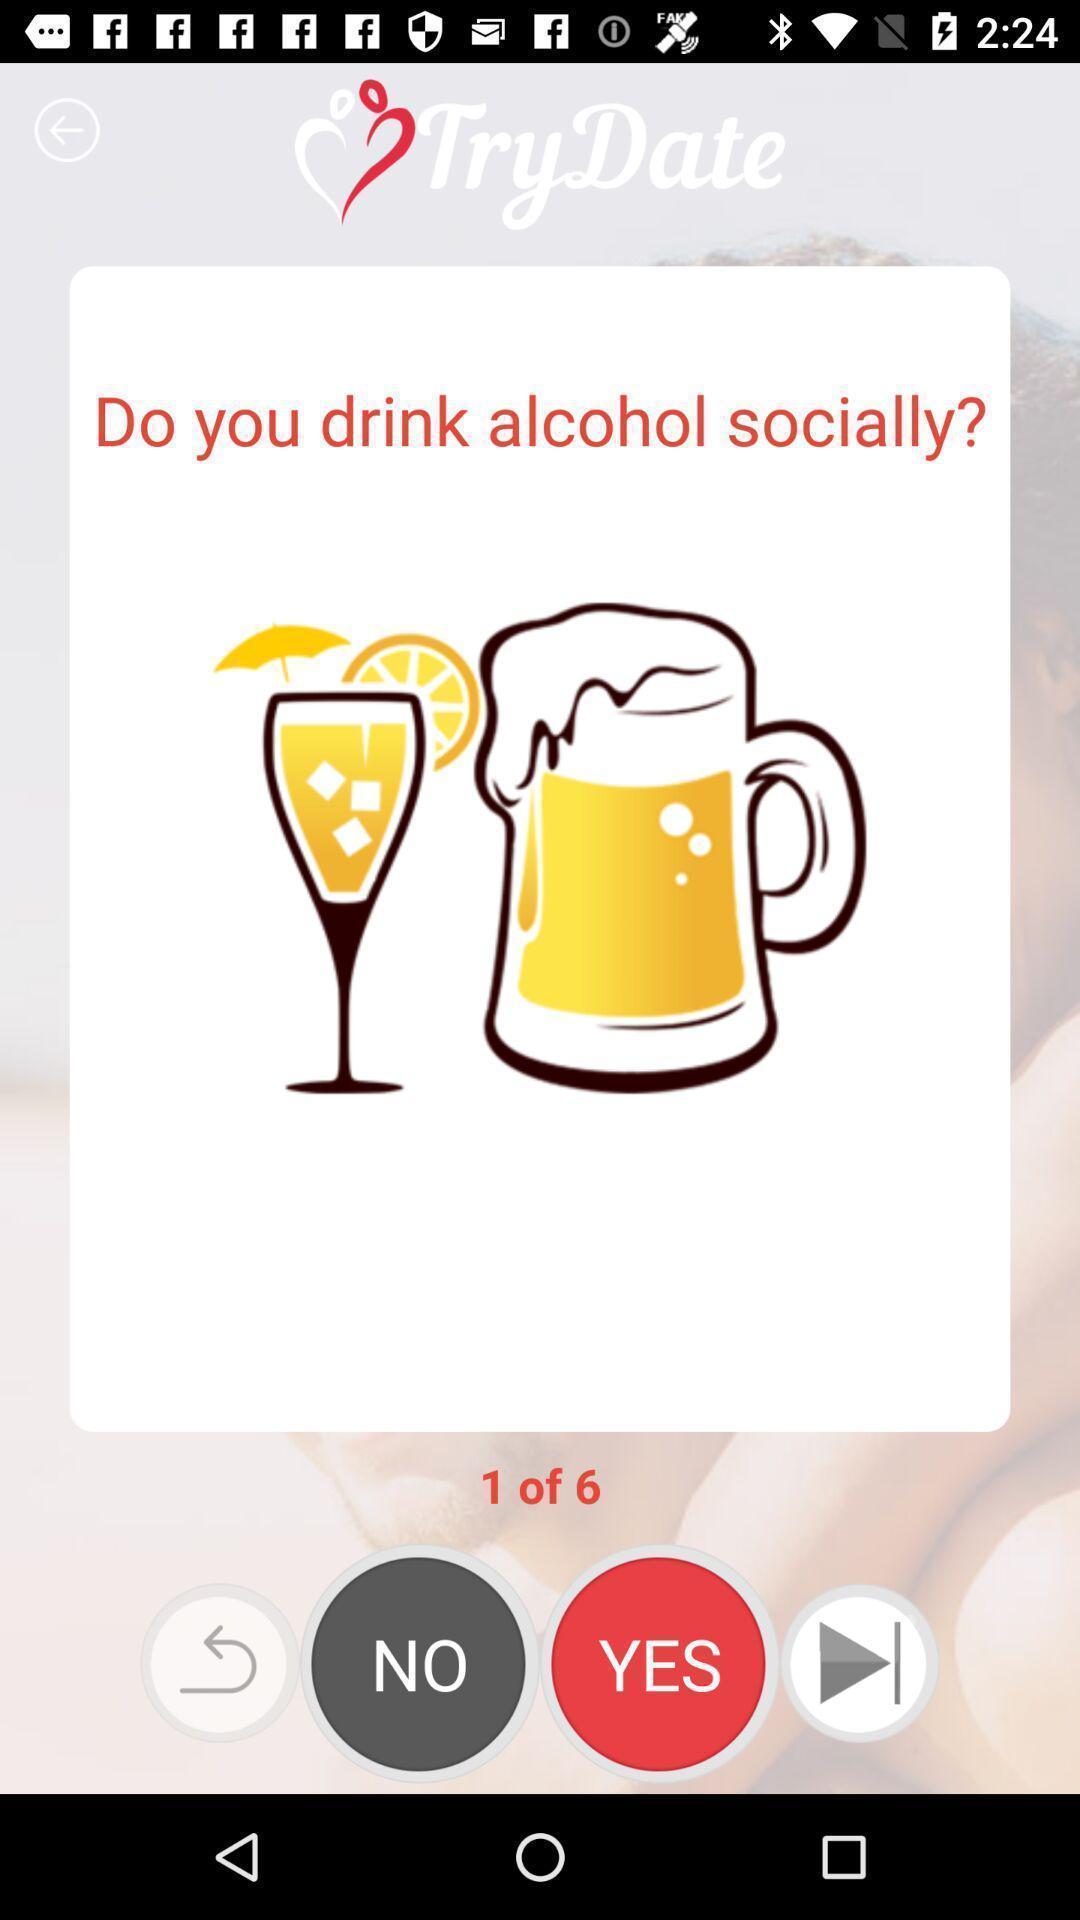Describe the key features of this screenshot. Screen displaying multiple options in a dating application. 